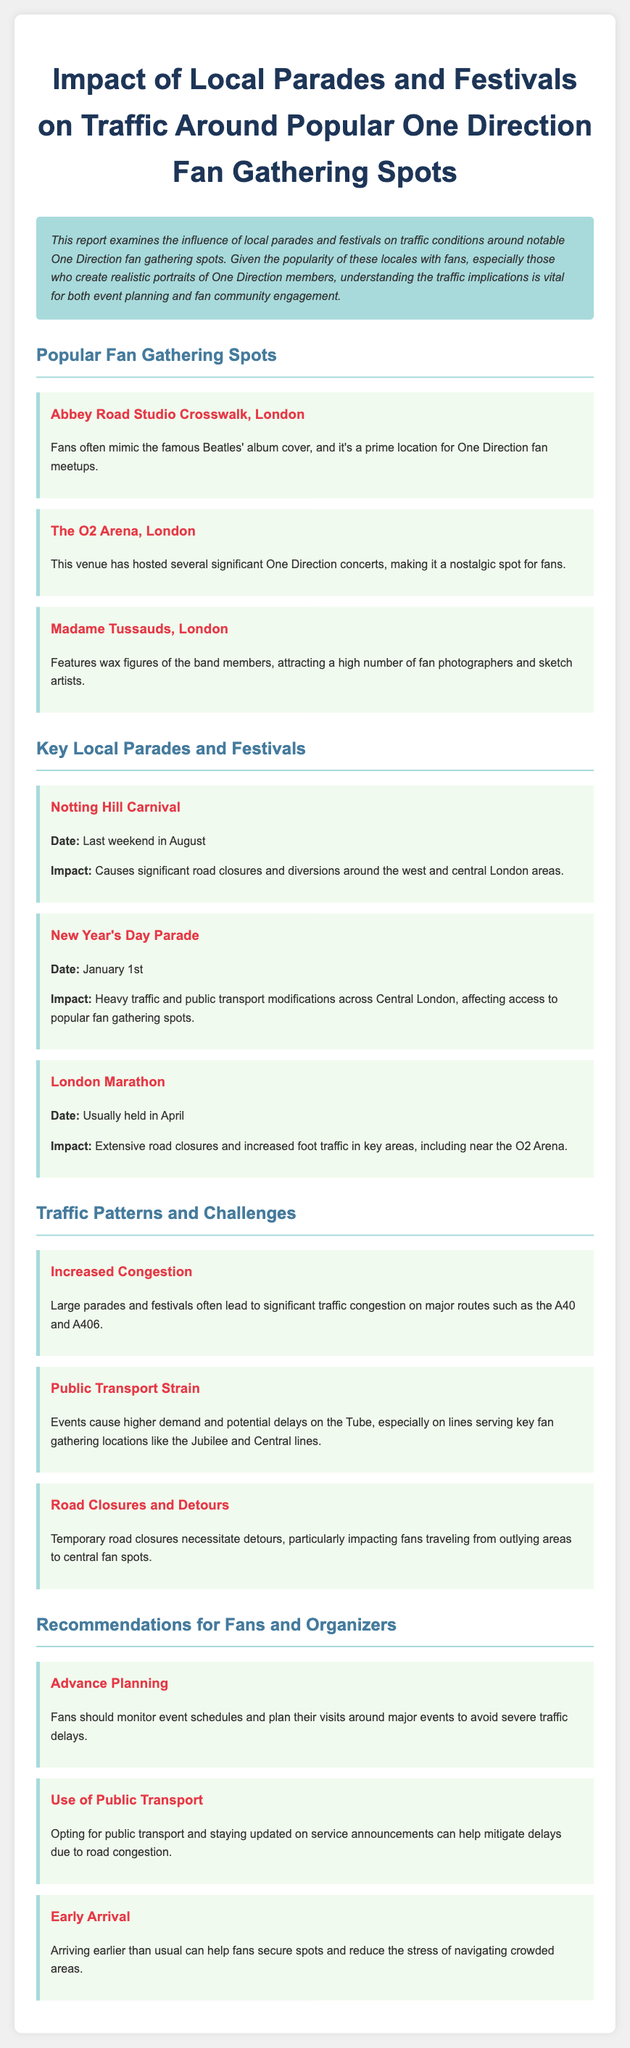What is the title of the report? The title of the report is mentioned at the top of the document, highlighting its focus on traffic related to fan gathering spots.
Answer: Impact of Local Parades and Festivals on Traffic Around Popular One Direction Fan Gathering Spots Which location features wax figures of One Direction members? The document specifies that Madame Tussauds is a popular fan gathering spot that features wax figures of the band members.
Answer: Madame Tussauds When is the Notting Hill Carnival held? The report details the date of the Notting Hill Carnival as the last weekend in August.
Answer: Last weekend in August What is one reason for increased congestion during local events? The report notes that large parades and festivals lead to significant traffic congestion on major routes.
Answer: Significant traffic congestion What should fans do to reduce stress during busy periods? The document recommends that fans arrive earlier than usual to help secure spots and reduce stress.
Answer: Arriving earlier What impact does the London Marathon have on traffic? The report states that the London Marathon causes extensive road closures and increased foot traffic in key areas.
Answer: Extensive road closures What type of transport is recommended for fans during events? The recommendations section advises fans to opt for public transport to mitigate delays due to road congestion.
Answer: Public transport What is a specific traffic challenge mentioned in the report? One observed challenge is the strain on public transport, which may lead to higher demand and potential delays.
Answer: Public transport strain 